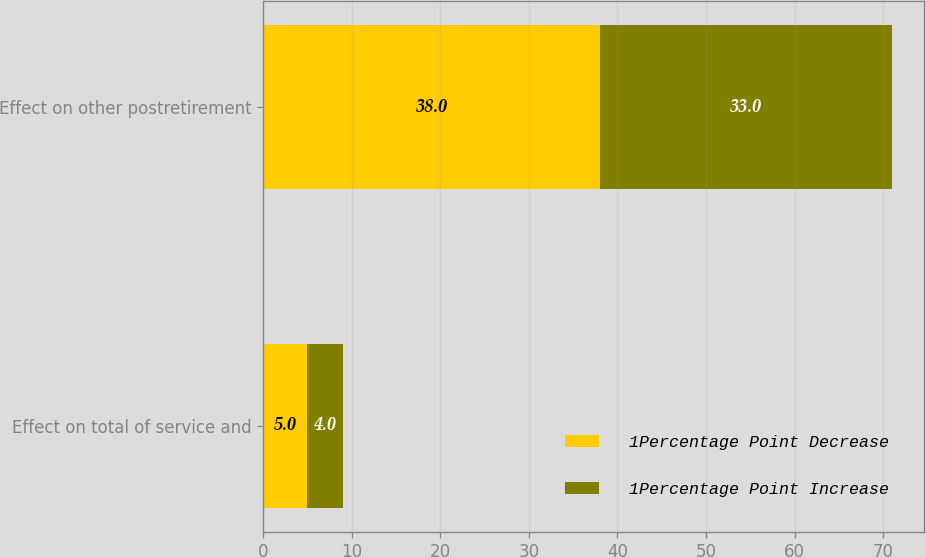Convert chart. <chart><loc_0><loc_0><loc_500><loc_500><stacked_bar_chart><ecel><fcel>Effect on total of service and<fcel>Effect on other postretirement<nl><fcel>1Percentage Point Decrease<fcel>5<fcel>38<nl><fcel>1Percentage Point Increase<fcel>4<fcel>33<nl></chart> 